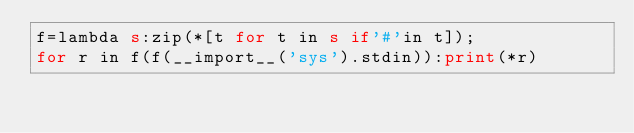<code> <loc_0><loc_0><loc_500><loc_500><_Perl_>f=lambda s:zip(*[t for t in s if'#'in t]);
for r in f(f(__import__('sys').stdin)):print(*r)</code> 